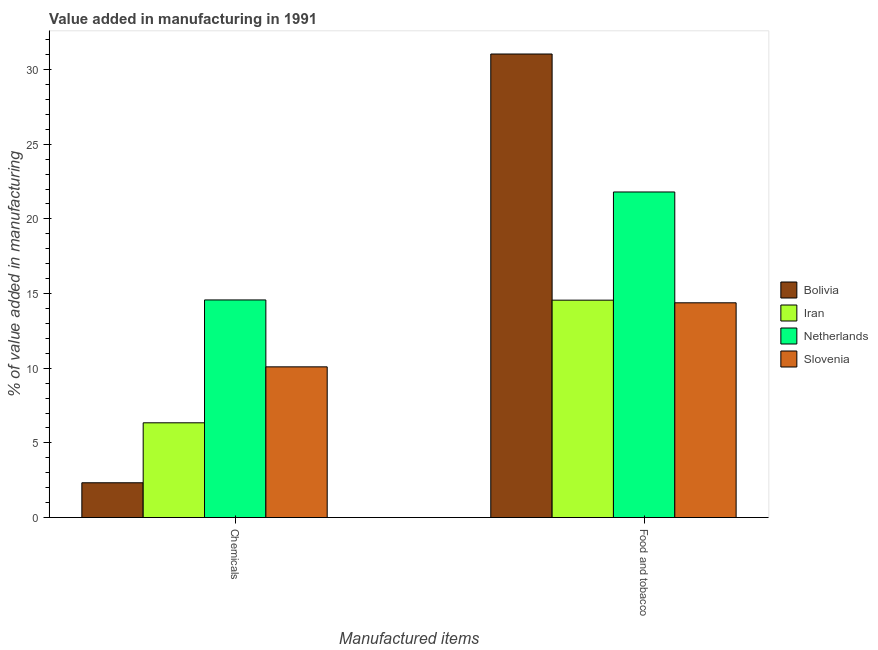How many groups of bars are there?
Keep it short and to the point. 2. What is the label of the 1st group of bars from the left?
Offer a terse response. Chemicals. What is the value added by  manufacturing chemicals in Iran?
Provide a short and direct response. 6.35. Across all countries, what is the maximum value added by  manufacturing chemicals?
Keep it short and to the point. 14.57. Across all countries, what is the minimum value added by  manufacturing chemicals?
Your answer should be very brief. 2.33. In which country was the value added by  manufacturing chemicals maximum?
Ensure brevity in your answer.  Netherlands. What is the total value added by manufacturing food and tobacco in the graph?
Give a very brief answer. 81.79. What is the difference between the value added by  manufacturing chemicals in Iran and that in Slovenia?
Provide a succinct answer. -3.75. What is the difference between the value added by manufacturing food and tobacco in Bolivia and the value added by  manufacturing chemicals in Netherlands?
Provide a succinct answer. 16.47. What is the average value added by manufacturing food and tobacco per country?
Your answer should be very brief. 20.45. What is the difference between the value added by  manufacturing chemicals and value added by manufacturing food and tobacco in Slovenia?
Give a very brief answer. -4.29. In how many countries, is the value added by  manufacturing chemicals greater than 25 %?
Make the answer very short. 0. What is the ratio of the value added by  manufacturing chemicals in Netherlands to that in Slovenia?
Provide a short and direct response. 1.44. Is the value added by manufacturing food and tobacco in Slovenia less than that in Iran?
Offer a very short reply. Yes. In how many countries, is the value added by  manufacturing chemicals greater than the average value added by  manufacturing chemicals taken over all countries?
Ensure brevity in your answer.  2. What does the 3rd bar from the left in Food and tobacco represents?
Your answer should be very brief. Netherlands. What does the 2nd bar from the right in Chemicals represents?
Keep it short and to the point. Netherlands. How many bars are there?
Provide a short and direct response. 8. How many countries are there in the graph?
Your response must be concise. 4. What is the difference between two consecutive major ticks on the Y-axis?
Your answer should be very brief. 5. Does the graph contain grids?
Provide a succinct answer. No. Where does the legend appear in the graph?
Give a very brief answer. Center right. How many legend labels are there?
Provide a short and direct response. 4. How are the legend labels stacked?
Offer a terse response. Vertical. What is the title of the graph?
Offer a very short reply. Value added in manufacturing in 1991. Does "Saudi Arabia" appear as one of the legend labels in the graph?
Provide a succinct answer. No. What is the label or title of the X-axis?
Offer a terse response. Manufactured items. What is the label or title of the Y-axis?
Give a very brief answer. % of value added in manufacturing. What is the % of value added in manufacturing of Bolivia in Chemicals?
Ensure brevity in your answer.  2.33. What is the % of value added in manufacturing in Iran in Chemicals?
Make the answer very short. 6.35. What is the % of value added in manufacturing of Netherlands in Chemicals?
Your response must be concise. 14.57. What is the % of value added in manufacturing in Slovenia in Chemicals?
Your response must be concise. 10.09. What is the % of value added in manufacturing of Bolivia in Food and tobacco?
Provide a short and direct response. 31.04. What is the % of value added in manufacturing in Iran in Food and tobacco?
Offer a terse response. 14.56. What is the % of value added in manufacturing of Netherlands in Food and tobacco?
Provide a short and direct response. 21.8. What is the % of value added in manufacturing of Slovenia in Food and tobacco?
Provide a short and direct response. 14.38. Across all Manufactured items, what is the maximum % of value added in manufacturing of Bolivia?
Offer a very short reply. 31.04. Across all Manufactured items, what is the maximum % of value added in manufacturing in Iran?
Your answer should be very brief. 14.56. Across all Manufactured items, what is the maximum % of value added in manufacturing in Netherlands?
Keep it short and to the point. 21.8. Across all Manufactured items, what is the maximum % of value added in manufacturing of Slovenia?
Your answer should be compact. 14.38. Across all Manufactured items, what is the minimum % of value added in manufacturing of Bolivia?
Offer a terse response. 2.33. Across all Manufactured items, what is the minimum % of value added in manufacturing of Iran?
Provide a short and direct response. 6.35. Across all Manufactured items, what is the minimum % of value added in manufacturing in Netherlands?
Your answer should be compact. 14.57. Across all Manufactured items, what is the minimum % of value added in manufacturing of Slovenia?
Provide a short and direct response. 10.09. What is the total % of value added in manufacturing in Bolivia in the graph?
Your answer should be compact. 33.37. What is the total % of value added in manufacturing in Iran in the graph?
Keep it short and to the point. 20.9. What is the total % of value added in manufacturing in Netherlands in the graph?
Make the answer very short. 36.38. What is the total % of value added in manufacturing of Slovenia in the graph?
Your answer should be very brief. 24.48. What is the difference between the % of value added in manufacturing of Bolivia in Chemicals and that in Food and tobacco?
Your answer should be very brief. -28.71. What is the difference between the % of value added in manufacturing of Iran in Chemicals and that in Food and tobacco?
Ensure brevity in your answer.  -8.21. What is the difference between the % of value added in manufacturing in Netherlands in Chemicals and that in Food and tobacco?
Your answer should be very brief. -7.23. What is the difference between the % of value added in manufacturing of Slovenia in Chemicals and that in Food and tobacco?
Offer a very short reply. -4.29. What is the difference between the % of value added in manufacturing in Bolivia in Chemicals and the % of value added in manufacturing in Iran in Food and tobacco?
Provide a succinct answer. -12.23. What is the difference between the % of value added in manufacturing in Bolivia in Chemicals and the % of value added in manufacturing in Netherlands in Food and tobacco?
Keep it short and to the point. -19.47. What is the difference between the % of value added in manufacturing in Bolivia in Chemicals and the % of value added in manufacturing in Slovenia in Food and tobacco?
Make the answer very short. -12.05. What is the difference between the % of value added in manufacturing in Iran in Chemicals and the % of value added in manufacturing in Netherlands in Food and tobacco?
Your response must be concise. -15.46. What is the difference between the % of value added in manufacturing of Iran in Chemicals and the % of value added in manufacturing of Slovenia in Food and tobacco?
Keep it short and to the point. -8.04. What is the difference between the % of value added in manufacturing in Netherlands in Chemicals and the % of value added in manufacturing in Slovenia in Food and tobacco?
Provide a succinct answer. 0.19. What is the average % of value added in manufacturing of Bolivia per Manufactured items?
Make the answer very short. 16.69. What is the average % of value added in manufacturing of Iran per Manufactured items?
Offer a very short reply. 10.45. What is the average % of value added in manufacturing in Netherlands per Manufactured items?
Make the answer very short. 18.19. What is the average % of value added in manufacturing in Slovenia per Manufactured items?
Ensure brevity in your answer.  12.24. What is the difference between the % of value added in manufacturing in Bolivia and % of value added in manufacturing in Iran in Chemicals?
Make the answer very short. -4.02. What is the difference between the % of value added in manufacturing of Bolivia and % of value added in manufacturing of Netherlands in Chemicals?
Ensure brevity in your answer.  -12.24. What is the difference between the % of value added in manufacturing in Bolivia and % of value added in manufacturing in Slovenia in Chemicals?
Provide a short and direct response. -7.76. What is the difference between the % of value added in manufacturing in Iran and % of value added in manufacturing in Netherlands in Chemicals?
Give a very brief answer. -8.23. What is the difference between the % of value added in manufacturing of Iran and % of value added in manufacturing of Slovenia in Chemicals?
Make the answer very short. -3.75. What is the difference between the % of value added in manufacturing in Netherlands and % of value added in manufacturing in Slovenia in Chemicals?
Provide a succinct answer. 4.48. What is the difference between the % of value added in manufacturing in Bolivia and % of value added in manufacturing in Iran in Food and tobacco?
Your response must be concise. 16.49. What is the difference between the % of value added in manufacturing of Bolivia and % of value added in manufacturing of Netherlands in Food and tobacco?
Make the answer very short. 9.24. What is the difference between the % of value added in manufacturing of Bolivia and % of value added in manufacturing of Slovenia in Food and tobacco?
Provide a short and direct response. 16.66. What is the difference between the % of value added in manufacturing of Iran and % of value added in manufacturing of Netherlands in Food and tobacco?
Provide a short and direct response. -7.24. What is the difference between the % of value added in manufacturing of Iran and % of value added in manufacturing of Slovenia in Food and tobacco?
Your answer should be very brief. 0.18. What is the difference between the % of value added in manufacturing of Netherlands and % of value added in manufacturing of Slovenia in Food and tobacco?
Keep it short and to the point. 7.42. What is the ratio of the % of value added in manufacturing in Bolivia in Chemicals to that in Food and tobacco?
Provide a short and direct response. 0.08. What is the ratio of the % of value added in manufacturing of Iran in Chemicals to that in Food and tobacco?
Offer a terse response. 0.44. What is the ratio of the % of value added in manufacturing in Netherlands in Chemicals to that in Food and tobacco?
Make the answer very short. 0.67. What is the ratio of the % of value added in manufacturing of Slovenia in Chemicals to that in Food and tobacco?
Give a very brief answer. 0.7. What is the difference between the highest and the second highest % of value added in manufacturing in Bolivia?
Your answer should be compact. 28.71. What is the difference between the highest and the second highest % of value added in manufacturing in Iran?
Offer a terse response. 8.21. What is the difference between the highest and the second highest % of value added in manufacturing in Netherlands?
Your response must be concise. 7.23. What is the difference between the highest and the second highest % of value added in manufacturing in Slovenia?
Ensure brevity in your answer.  4.29. What is the difference between the highest and the lowest % of value added in manufacturing in Bolivia?
Provide a short and direct response. 28.71. What is the difference between the highest and the lowest % of value added in manufacturing of Iran?
Your answer should be very brief. 8.21. What is the difference between the highest and the lowest % of value added in manufacturing in Netherlands?
Provide a short and direct response. 7.23. What is the difference between the highest and the lowest % of value added in manufacturing of Slovenia?
Provide a short and direct response. 4.29. 